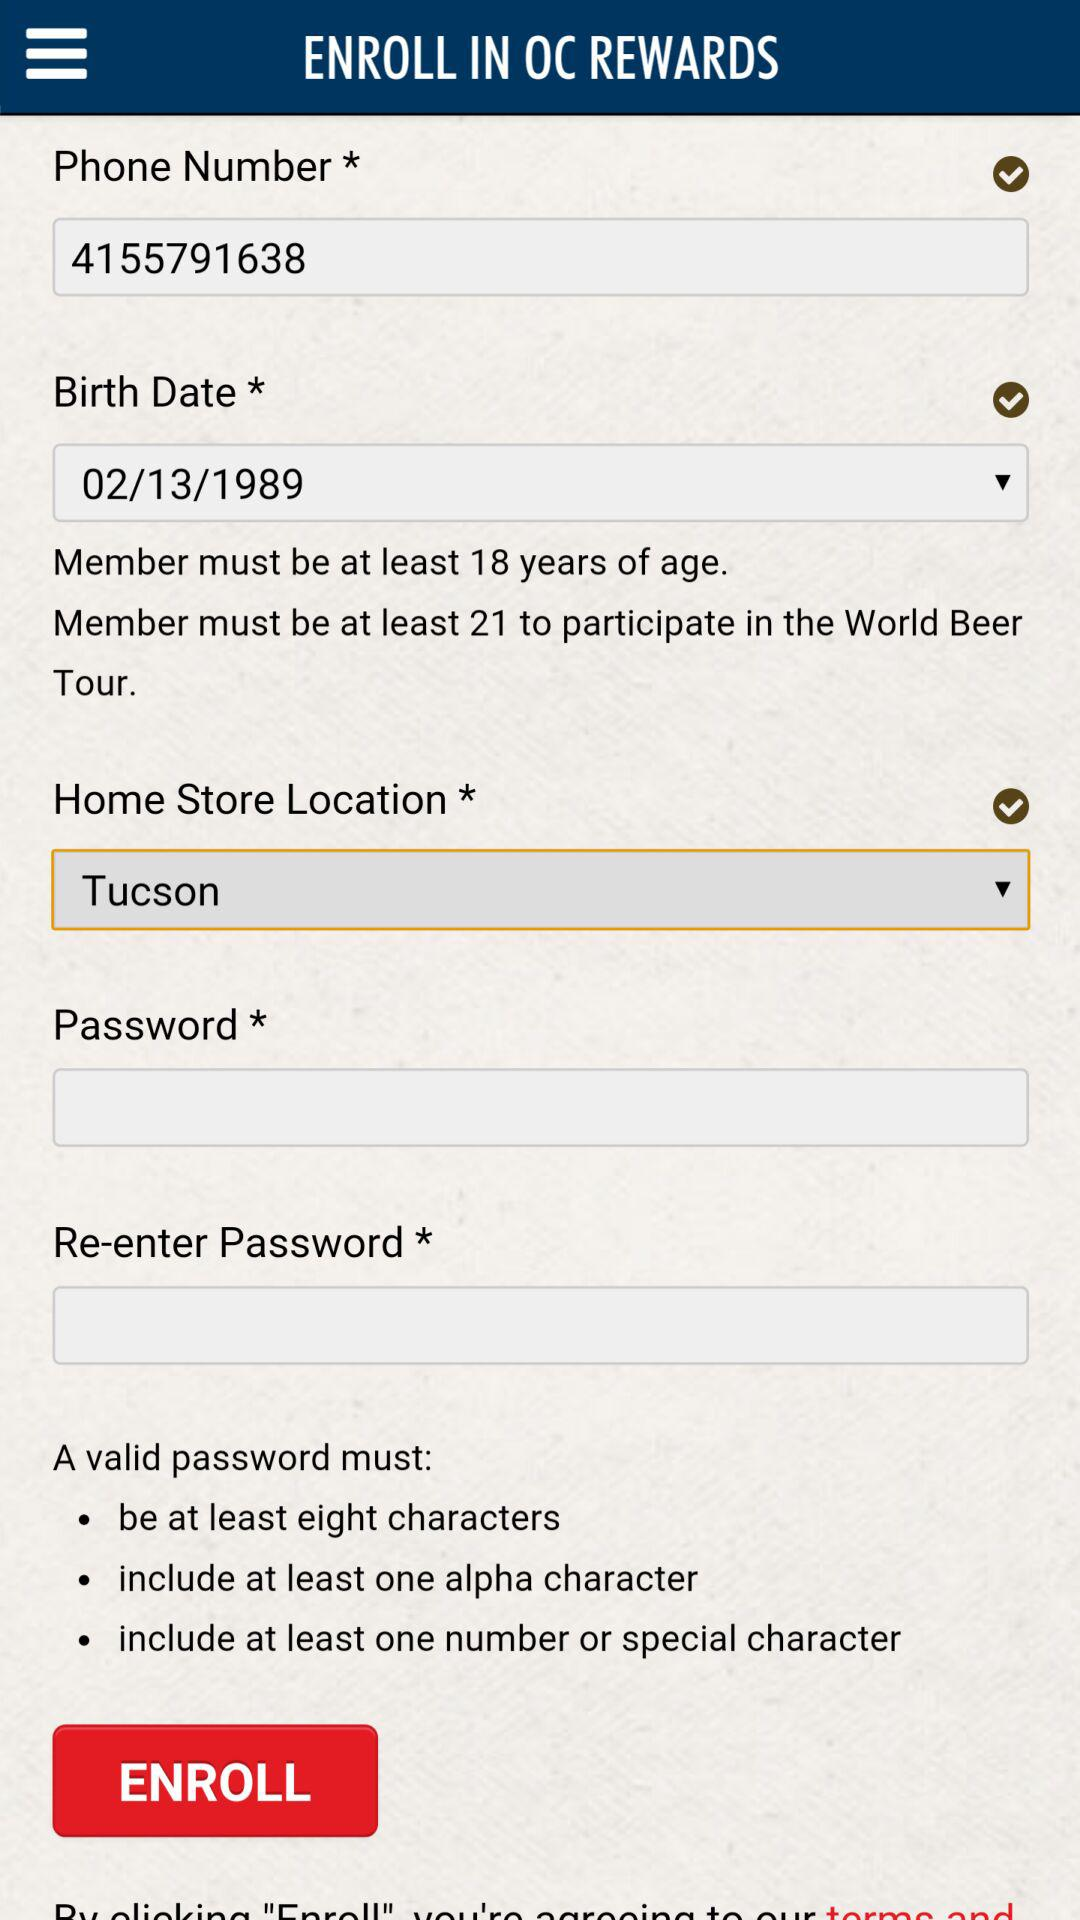What is the selected date of birth? The selected date of birth is February 13, 1989. 